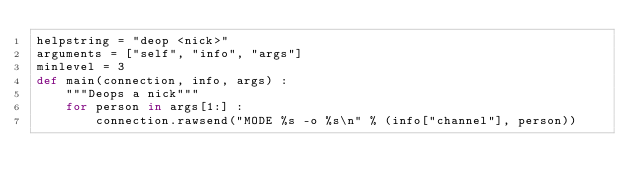Convert code to text. <code><loc_0><loc_0><loc_500><loc_500><_Python_>helpstring = "deop <nick>"
arguments = ["self", "info", "args"]
minlevel = 3
def main(connection, info, args) :
    """Deops a nick"""
    for person in args[1:] :
        connection.rawsend("MODE %s -o %s\n" % (info["channel"], person))
</code> 